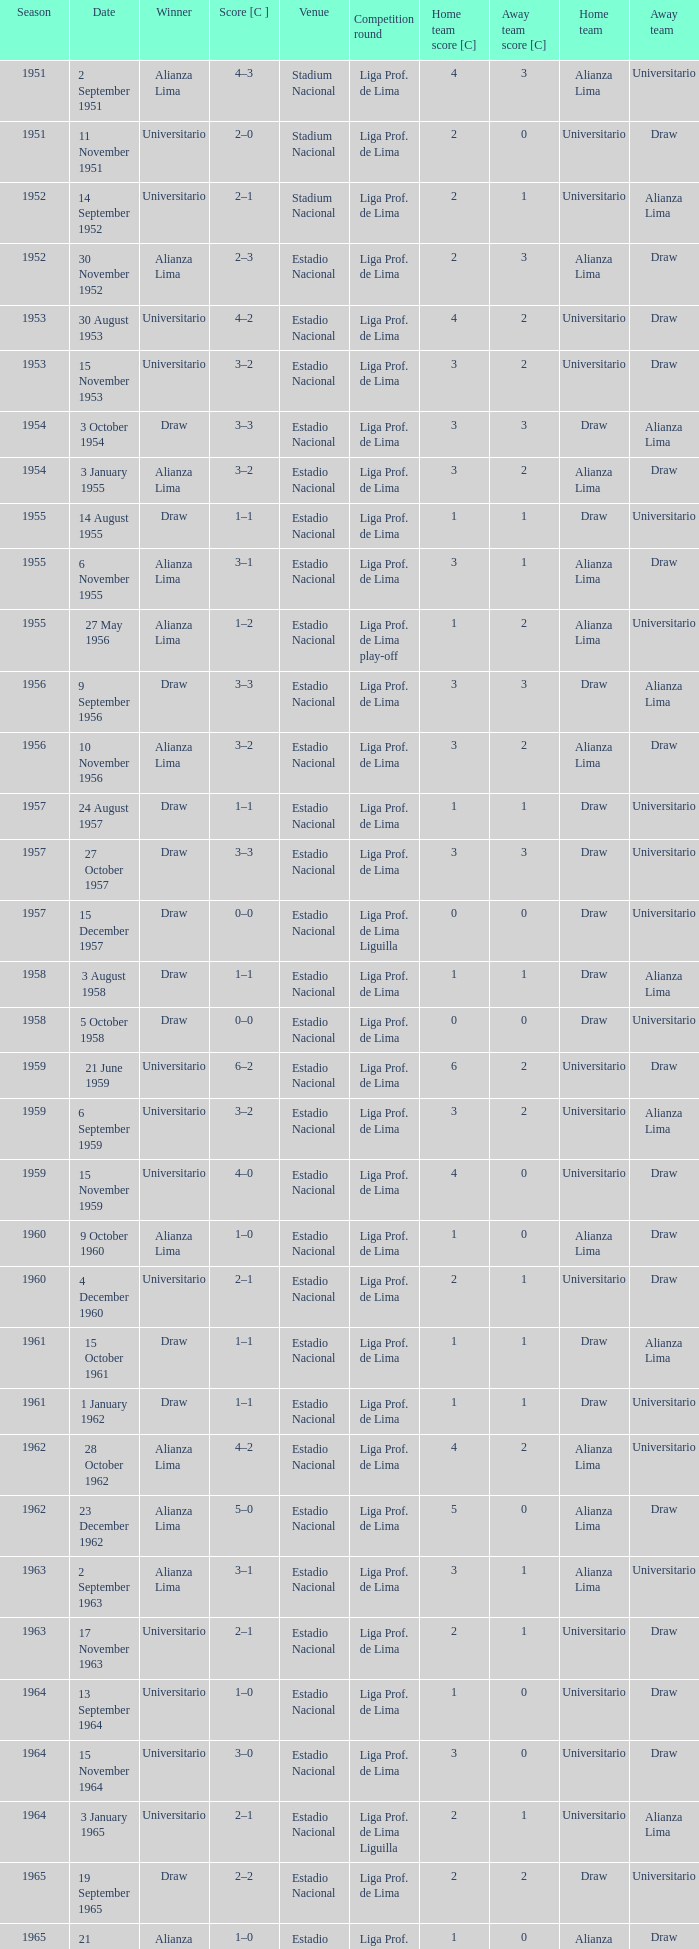What is the most recent season with a date of 27 October 1957? 1957.0. 